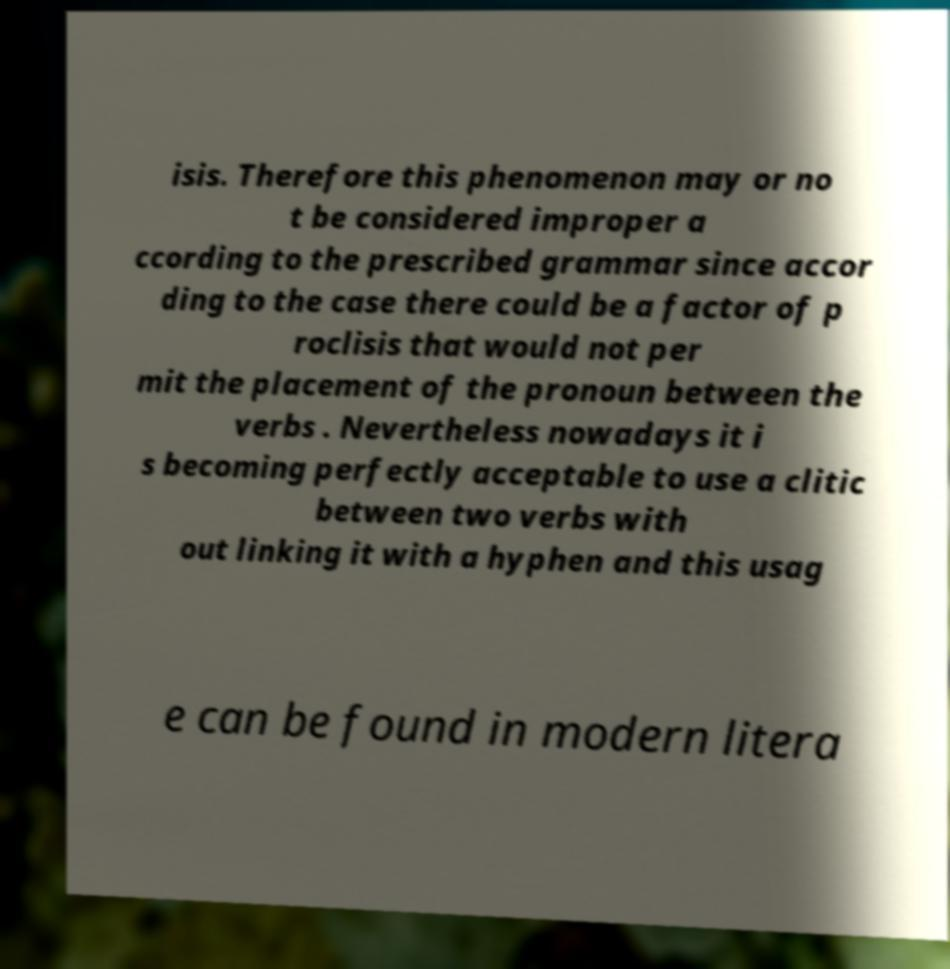Could you assist in decoding the text presented in this image and type it out clearly? isis. Therefore this phenomenon may or no t be considered improper a ccording to the prescribed grammar since accor ding to the case there could be a factor of p roclisis that would not per mit the placement of the pronoun between the verbs . Nevertheless nowadays it i s becoming perfectly acceptable to use a clitic between two verbs with out linking it with a hyphen and this usag e can be found in modern litera 